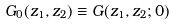<formula> <loc_0><loc_0><loc_500><loc_500>G _ { 0 } ( z _ { 1 } , z _ { 2 } ) \equiv G ( z _ { 1 } , z _ { 2 } ; 0 )</formula> 